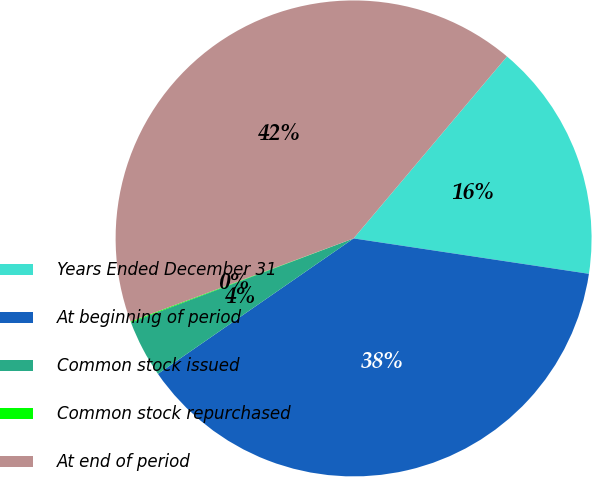<chart> <loc_0><loc_0><loc_500><loc_500><pie_chart><fcel>Years Ended December 31<fcel>At beginning of period<fcel>Common stock issued<fcel>Common stock repurchased<fcel>At end of period<nl><fcel>16.23%<fcel>37.99%<fcel>3.9%<fcel>0.06%<fcel>41.83%<nl></chart> 